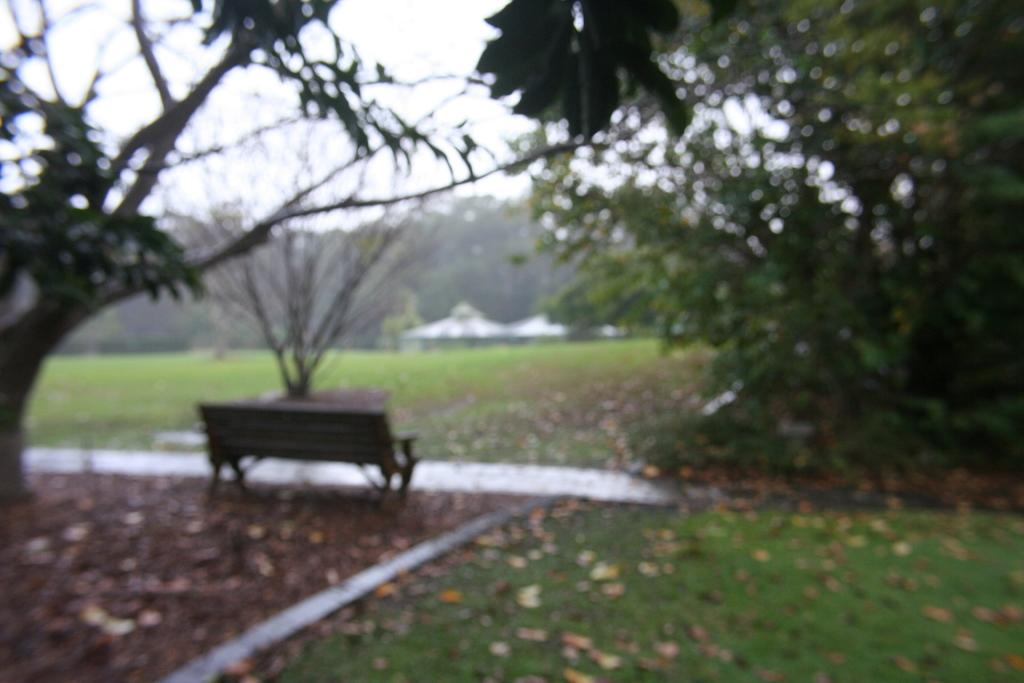What type of surface can be seen in the image? Ground is visible in the image. What type of seating is present in the image? There is a bench in the image. What type of vegetation is present in the image? Trees and grass are visible in the image. What type of structures are present in the image? Houses are visible in the image. What additional details can be observed on the ground? Dried leaves are present in the image. What is visible in the background of the image? The sky is visible in the image. What type of metal is used to make the chess pieces in the image? There are no chess pieces present in the image, so it is not possible to determine the type of metal used. 